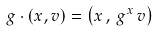Convert formula to latex. <formula><loc_0><loc_0><loc_500><loc_500>g \cdot ( x , v ) = \left ( x \, , \, g ^ { x } \, v \right )</formula> 